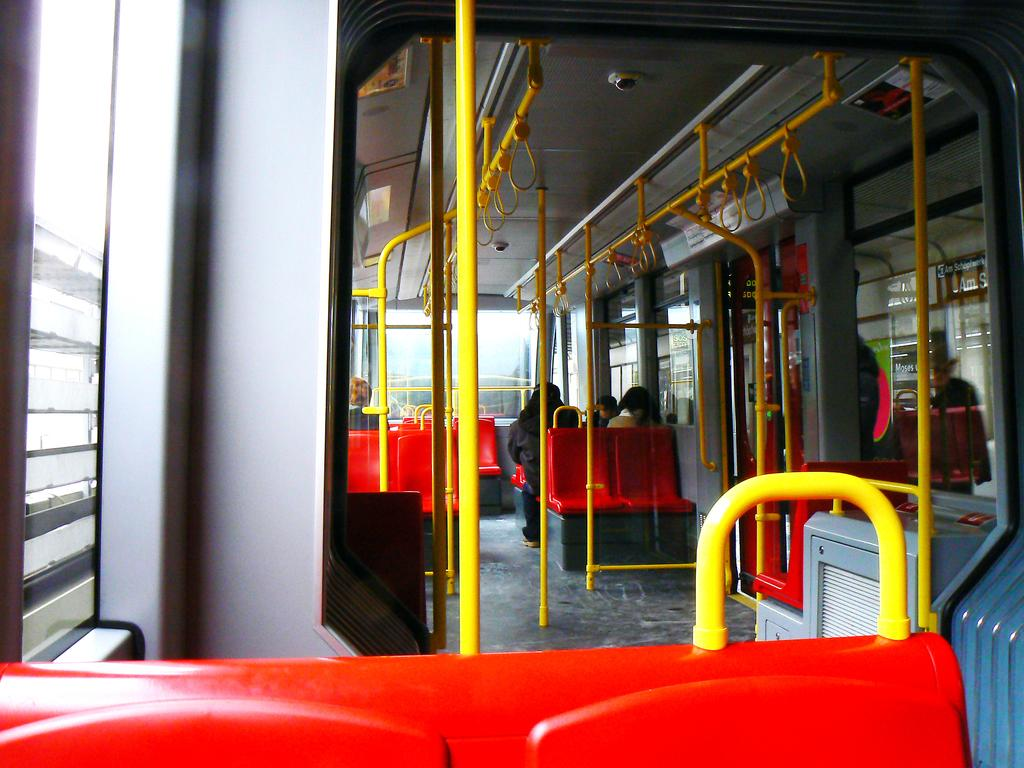What color are the seats in the image? The seats in the image are red. What other objects can be seen in the image besides the seats? There are yellow rods and handles in the image. Are there any people in the image? Yes, people are present in the image. What is located on the left side of the image? There is a window on the left side of the image. What type of pear is being used as a doorstop in the image? There is no pear present in the image, and therefore no such object is being used as a doorstop. 